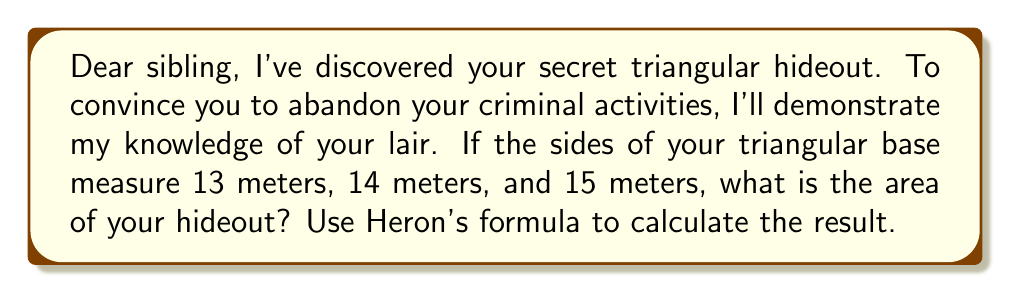Solve this math problem. To solve this problem, we'll use Heron's formula:

1) Heron's formula states that the area $A$ of a triangle with sides $a$, $b$, and $c$ is:

   $$A = \sqrt{s(s-a)(s-b)(s-c)}$$

   where $s$ is the semi-perimeter: $s = \frac{a+b+c}{2}$

2) Given sides: $a = 13$ m, $b = 14$ m, $c = 15$ m

3) Calculate the semi-perimeter:
   $$s = \frac{13+14+15}{2} = \frac{42}{2} = 21$$

4) Now, substitute into Heron's formula:
   $$A = \sqrt{21(21-13)(21-14)(21-15)}$$
   $$= \sqrt{21 \cdot 8 \cdot 7 \cdot 6}$$
   $$= \sqrt{7056}$$
   $$= 84$$

Therefore, the area of the triangular hideout is 84 square meters.
Answer: 84 m² 